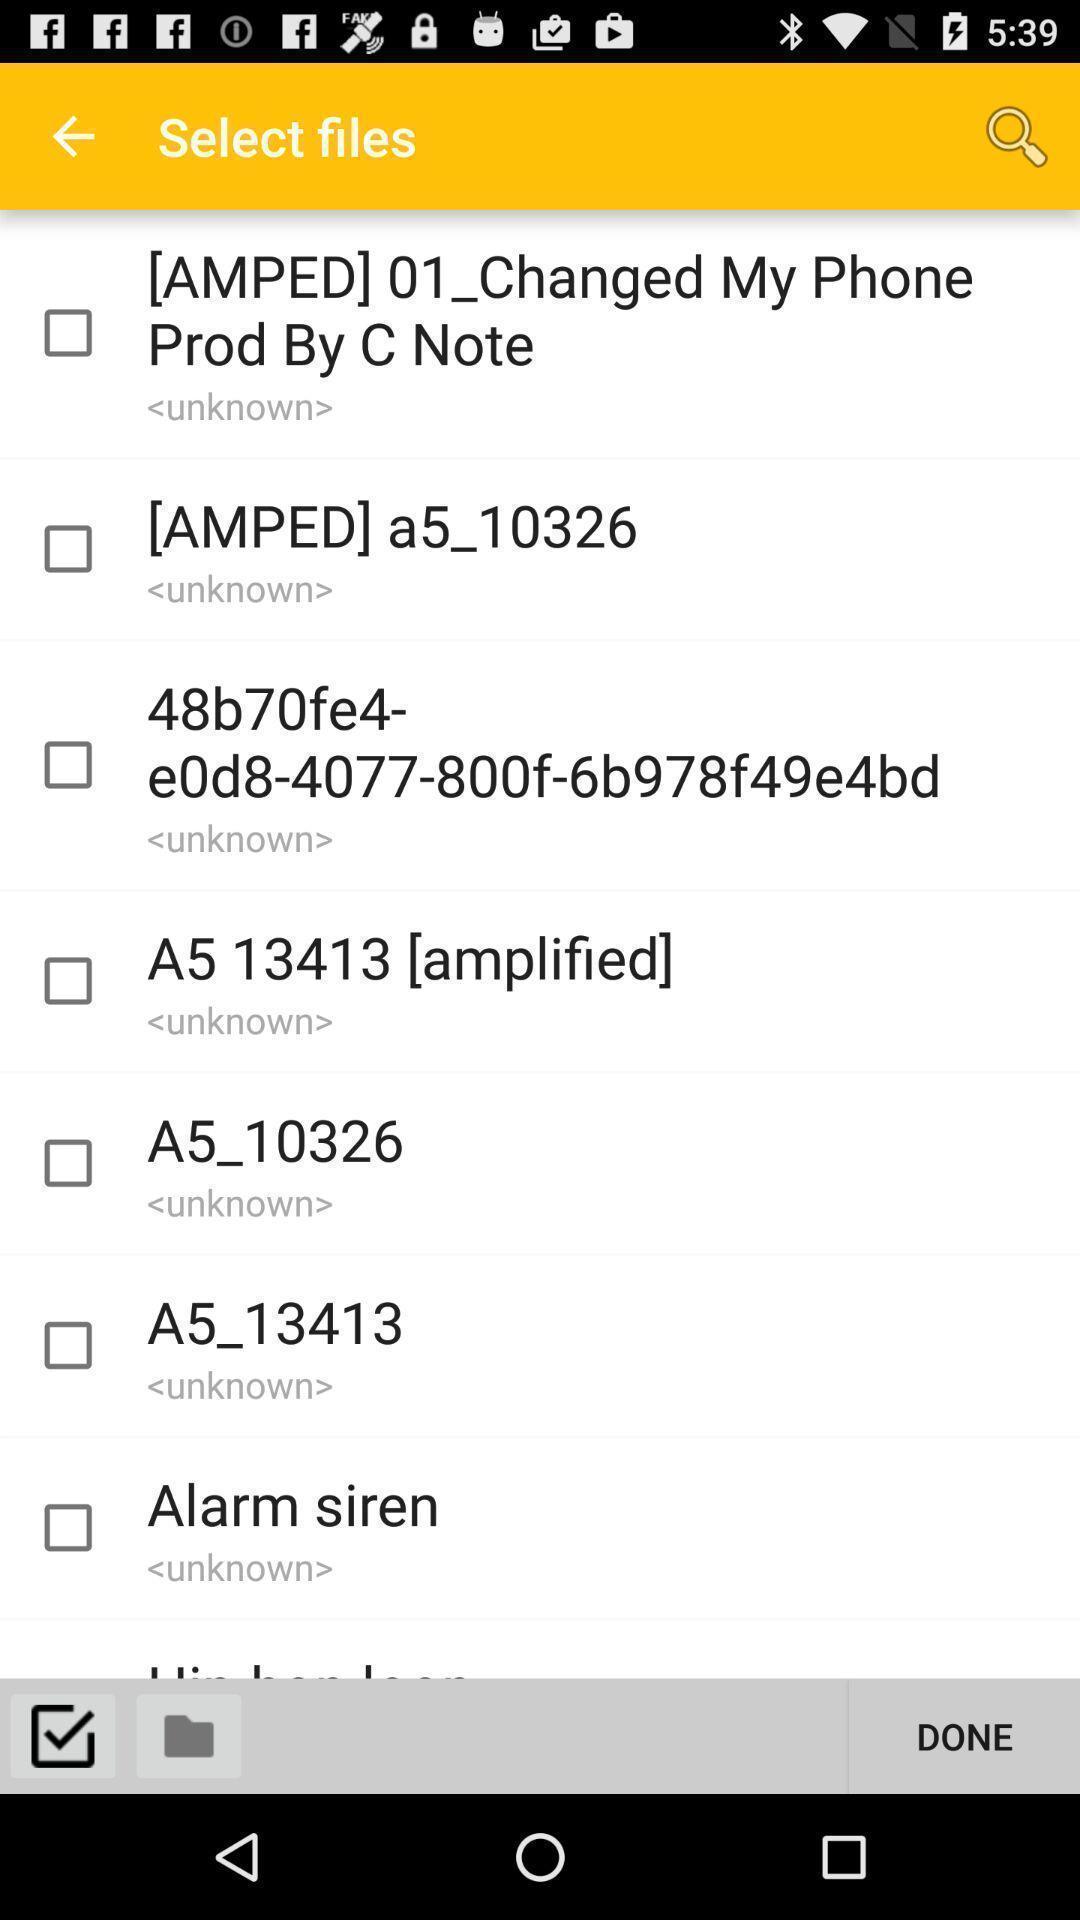Explain the elements present in this screenshot. Page displays to select files in app. 